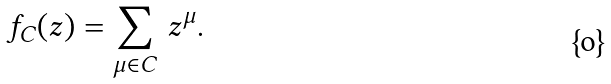<formula> <loc_0><loc_0><loc_500><loc_500>f _ { C } ( z ) = \sum _ { \mu \in C } \, z ^ { \mu } .</formula> 